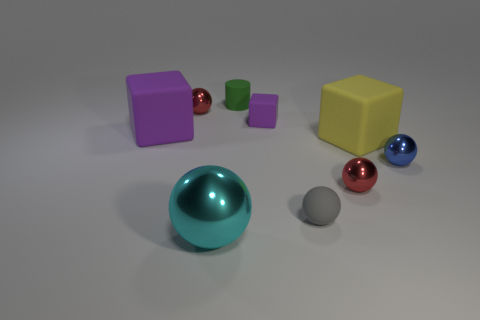Is there any other thing that has the same color as the matte ball?
Keep it short and to the point. No. There is a cube that is right of the gray ball; how big is it?
Make the answer very short. Large. What is the size of the rubber cube that is to the right of the matte cube behind the purple block that is to the left of the cyan thing?
Ensure brevity in your answer.  Large. What color is the small rubber thing that is in front of the big cube behind the yellow matte object?
Keep it short and to the point. Gray. What material is the gray object that is the same shape as the cyan metal object?
Offer a very short reply. Rubber. There is a green object; are there any purple rubber objects to the right of it?
Provide a succinct answer. Yes. How many large purple matte objects are there?
Give a very brief answer. 1. There is a red shiny sphere that is left of the cyan shiny sphere; what number of tiny metal balls are right of it?
Your answer should be very brief. 2. There is a small block; is its color the same as the rubber object that is left of the tiny green matte cylinder?
Your response must be concise. Yes. What number of gray objects are the same shape as the large purple matte object?
Provide a succinct answer. 0. 